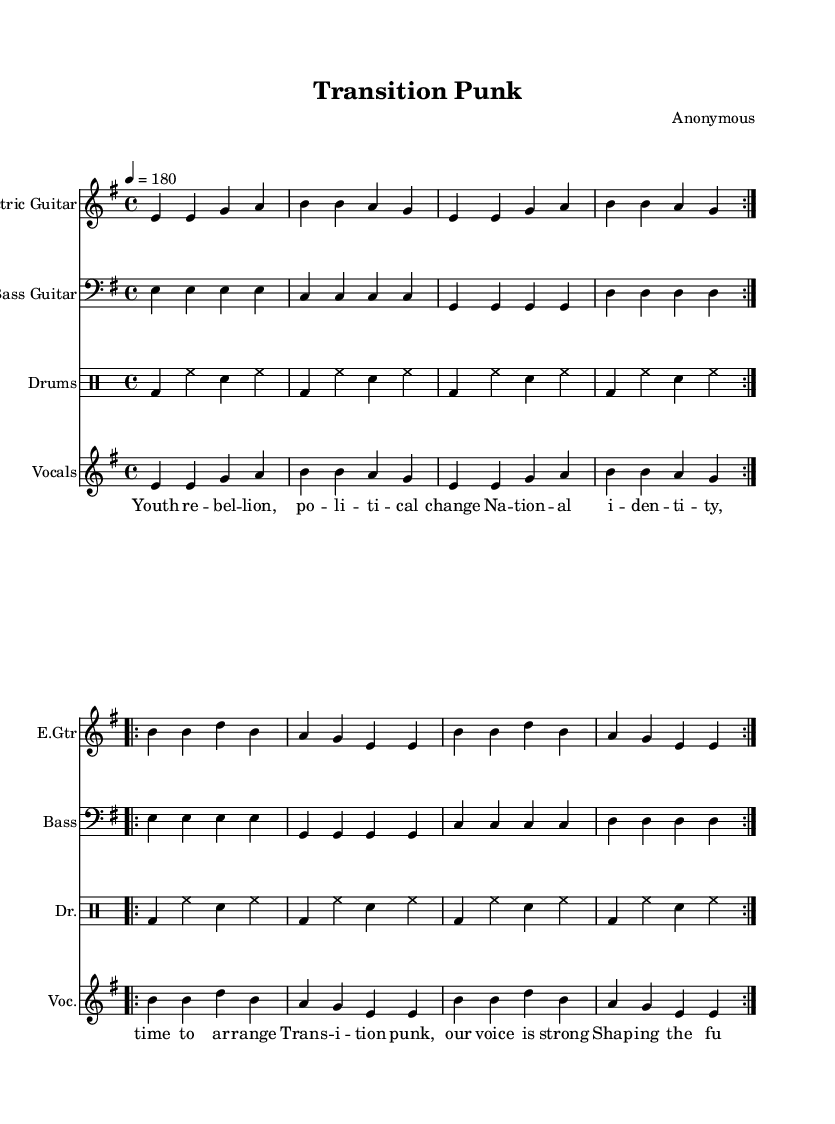What is the key signature of this music? The key signature is E minor, which has one sharp (F#). This is indicated at the beginning of the staff where the sharps are shown.
Answer: E minor What is the time signature of this music? The time signature is 4/4, which is noted at the beginning of the music. It indicates that there are four beats in each measure and a quarter note receives one beat.
Answer: 4/4 What is the tempo marking of this music? The tempo marking is indicated as "4 = 180," which means that there should be 180 beats per minute, and the quarter note is used as the unit of time.
Answer: 180 How many sections does the electric guitar part repeat? The electric guitar part repeats 2 times; this is indicated by the "volta" markings and the repetitions shown in the notation.
Answer: 2 What is the dynamic feel of the drums part based on the notation? The drums part includes consistent bass drum hits followed by hi-hat and snare, indicating a driving and energetic feel typical of punk music. The repeated pattern suggests a strong, steady rhythm which is common in punk rock.
Answer: Driving What lyrics are associated with the vocals part? The lyrics go "Youth rebellion, political change, National identity, time to arrange, Transition punk, our voice is strong, Shaping the future, where we belong." These lyrics embody themes of advocacy and identity formation, characteristic of punk music.
Answer: Political change What instruments are included in this score? The score includes electric guitar, bass guitar, drums, and vocals. Each instrument is clearly labeled at the start of its staff in the sheet music.
Answer: Electric guitar, bass guitar, drums, vocals 